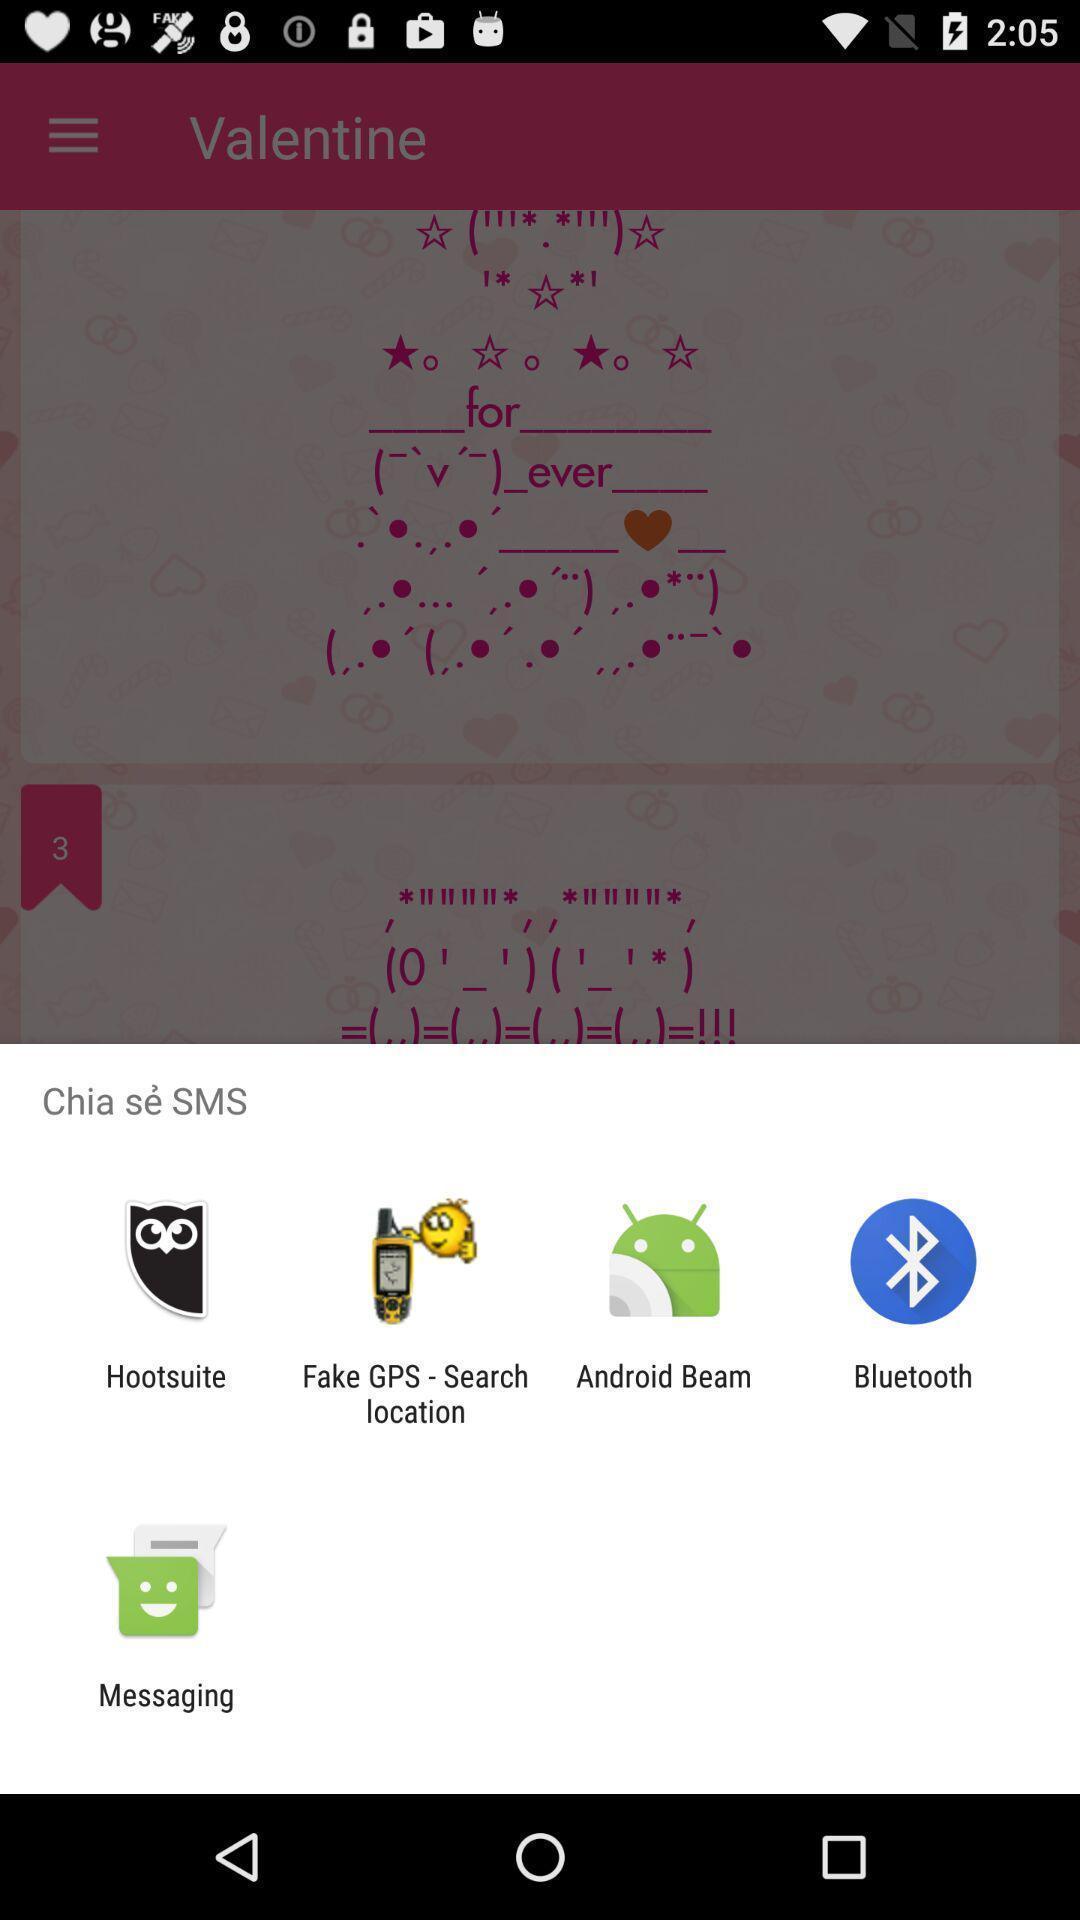Summarize the information in this screenshot. Pop-up widget showing many data sharing apps. 